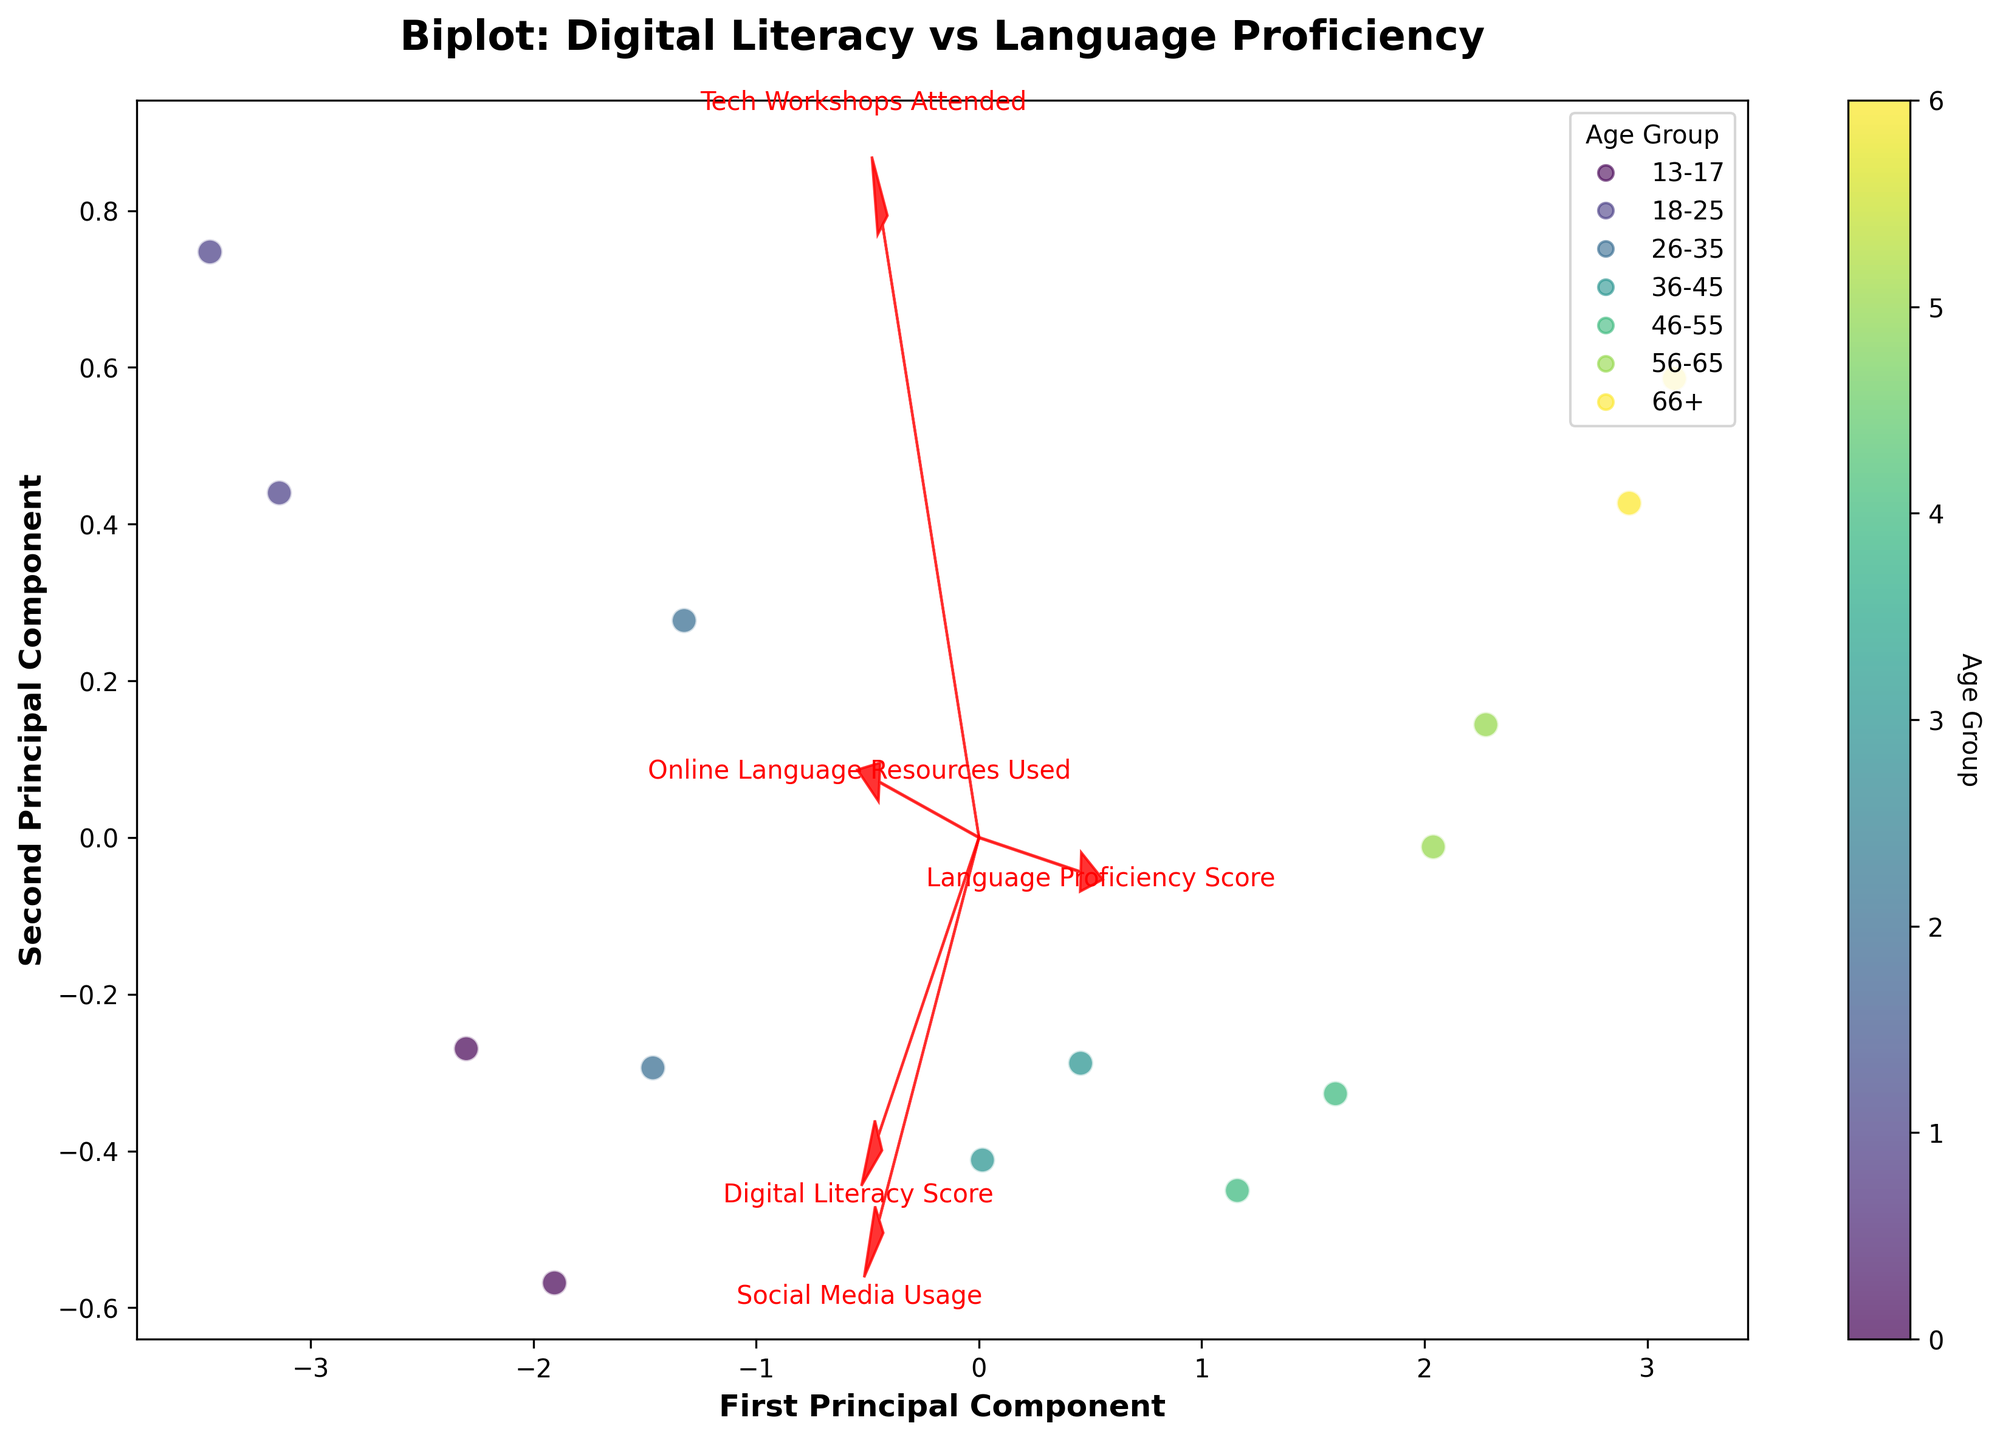What does the title of the biplot indicate? The title "Biplot: Digital Literacy vs Language Proficiency" indicates that the biplot visualizes the relationship between digital literacy skills and language proficiency among different age groups. The biplot is a combined plot that shows both the observations (age groups) and the variables (features like digital literacy score, etc.).
Answer: It shows the relationship between digital literacy and language proficiency by age group How many age groups are shown in the biplot? To determine the number of age groups, look at the distinct categories used for the color coding in the scatter plot. Each unique color represents a different age group. By counting these unique colors, one can identify the number of age groups.
Answer: 7 Which age group shows the highest digital literacy score in the biplot? To find this, we can look at the direction of the "Digital Literacy Score" arrow. Age groups that are farthest in that direction would have the highest digital literacy scores. Looking at the plot, the 18-25 age group appears to be the farthest along in the direction of the "Digital Literacy Score" arrow.
Answer: 18-25 Which features seem to contribute most to the first principal component? Identify which feature arrows have the largest projections onto the first principal component axis (horizontal axis). In the biplot, "Digital Literacy Score" and "Social Media Usage" arrows extend furthest horizontally, indicating that they contribute most to the first principal component.
Answer: Digital Literacy Score and Social Media Usage How does the tech workshops attended vary across different age groups? Observe the direction and length of the "Tech Workshops Attended" vector. Age groups close to the tip of this vector attended more workshops. Conversely, age groups located far from it attended fewer or no workshops. This shows that younger age groups tend to attend more tech workshops compared to older age groups.
Answer: Younger age groups attend more workshops Compare the social media usage between the 13-17 age group and the 56-65 age group. The "Social Media Usage" vector should be observed. The 13-17 age group will be close to the tip of this vector, showing high usage, while the 56-65 age group will be farther from this vector's tip, indicating lower usage.
Answer: 13-17 age group uses more social media than the 56-65 age group Which age group shows the highest language proficiency score? Look at the placement of data points in relation to the "Language Proficiency Score" arrow. Age groups located furthest along this arrow direction have the highest proficiency scores. Observing the plot, the 66+ age group appears farthest in the direction of this vector.
Answer: 66+ Explain how digital literacy is related to language proficiency according to the biplot. Examine the angles between the vectors of "Digital Literacy Score" and "Language Proficiency Score." If they are nearly orthogonal, it suggests little to no correlation. If they form a small or obtuse angle, it suggests a positive or negative correlation. The biplot shows that these vectors are nearly orthogonal, indicating minimal direct correlation between digital literacy and language proficiency.
Answer: There is minimal correlation 